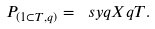<formula> <loc_0><loc_0><loc_500><loc_500>P _ { ( 1 \subset T , q ) } = \ s y q { X } { q } { T } .</formula> 